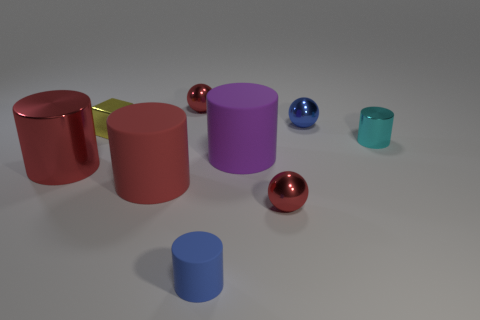The tiny rubber cylinder has what color? blue 